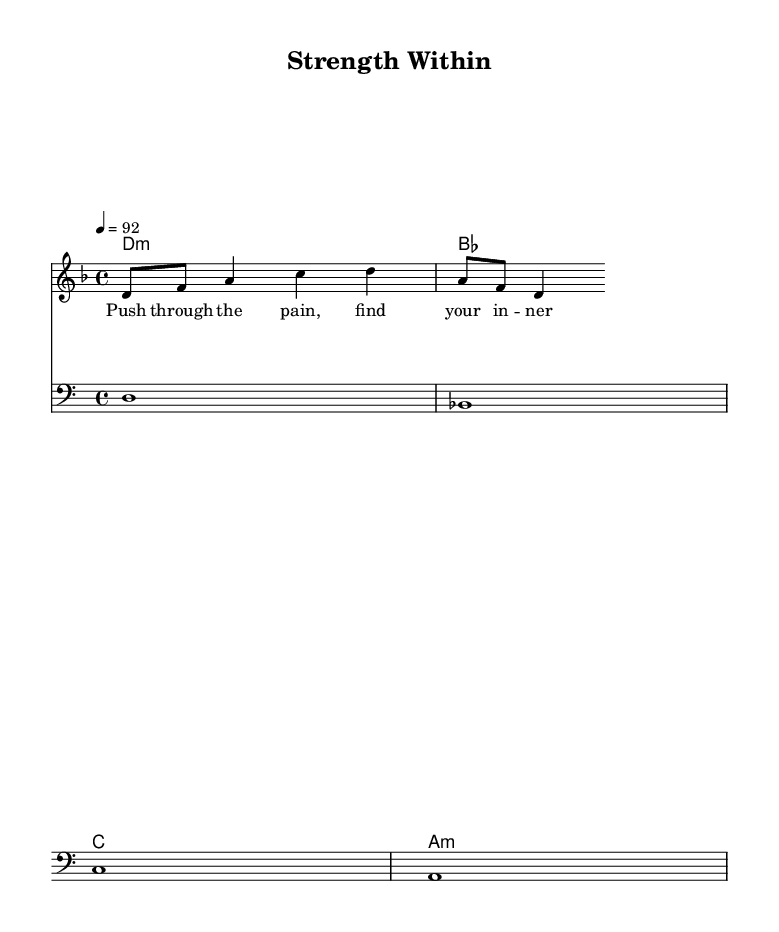What is the key signature of this music? The key signature is D minor, which has one flat (B flat). This can be determined by looking at the beginning of the staff where the key signature is displayed.
Answer: D minor What is the time signature of this music? The time signature is 4/4, which indicates that there are four beats in a measure, and the quarter note gets one beat. This can be seen at the start of the sheet music.
Answer: 4/4 What is the tempo marking for this music? The tempo marking is 92 beats per minute. This is indicated in the score notation as "4 = 92," which tells the performer the speed at which to play the piece.
Answer: 92 How many measures are in the melody? The melody consists of two measures, which can be counted by looking at the grouping of notes, each separated by bar lines.
Answer: 2 What is the first lyric line of the song? The first lyric line is "Push through the pain, find your in -- ner might." This is found below the melody staff and indicates the text associated with the notes.
Answer: Push through the pain, find your in -- ner might What type of chords are indicated in the harmonies? The harmonies include D minor, B flat major, C major, and A minor chords. These chords can be identified by looking at the chord names written above the staff, which suggest the harmonic structure of the piece.
Answer: D minor, B flat, C, A minor What clef is used for the bassline? The clef used for the bassline is the bass clef, which can be identified at the beginning of the bassline staff. This clef indicates that the notes are played in a lower range.
Answer: Bass clef 